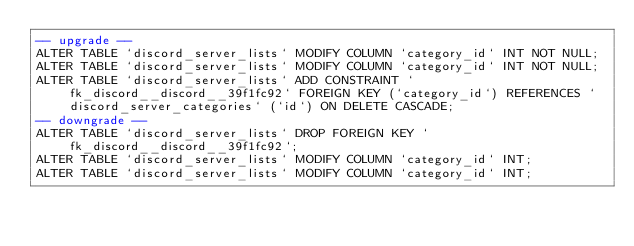<code> <loc_0><loc_0><loc_500><loc_500><_SQL_>-- upgrade --
ALTER TABLE `discord_server_lists` MODIFY COLUMN `category_id` INT NOT NULL;
ALTER TABLE `discord_server_lists` MODIFY COLUMN `category_id` INT NOT NULL;
ALTER TABLE `discord_server_lists` ADD CONSTRAINT `fk_discord__discord__39f1fc92` FOREIGN KEY (`category_id`) REFERENCES `discord_server_categories` (`id`) ON DELETE CASCADE;
-- downgrade --
ALTER TABLE `discord_server_lists` DROP FOREIGN KEY `fk_discord__discord__39f1fc92`;
ALTER TABLE `discord_server_lists` MODIFY COLUMN `category_id` INT;
ALTER TABLE `discord_server_lists` MODIFY COLUMN `category_id` INT;
</code> 